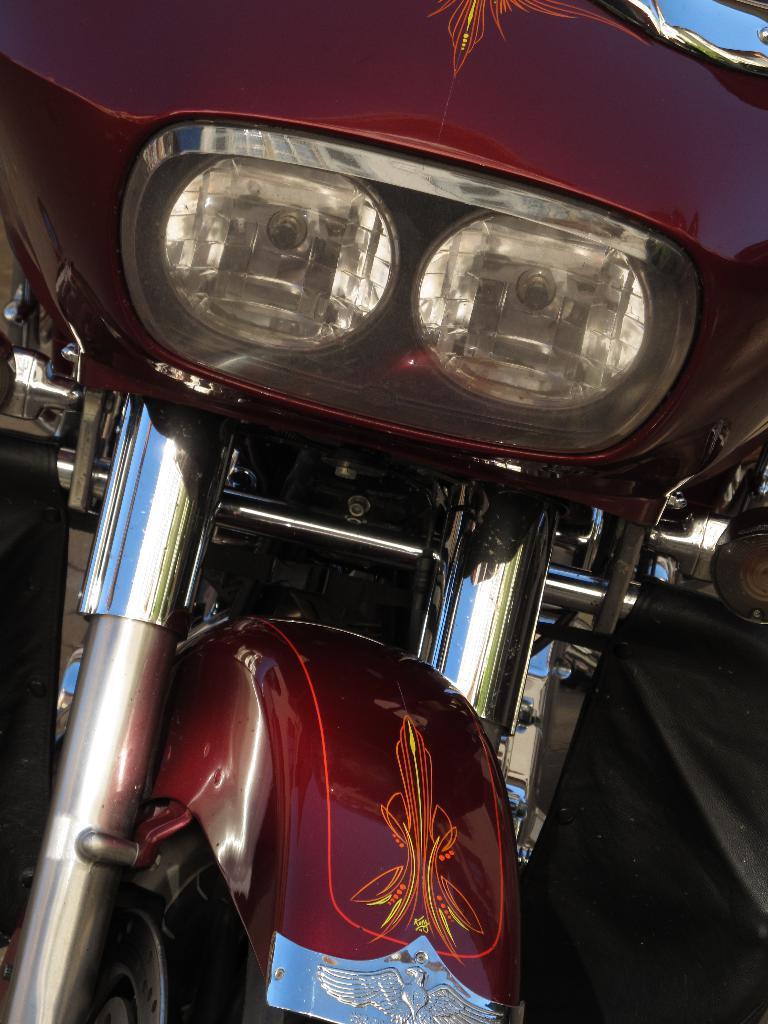Can you describe this image briefly? It is a zoomed in picture of a vehicle. 